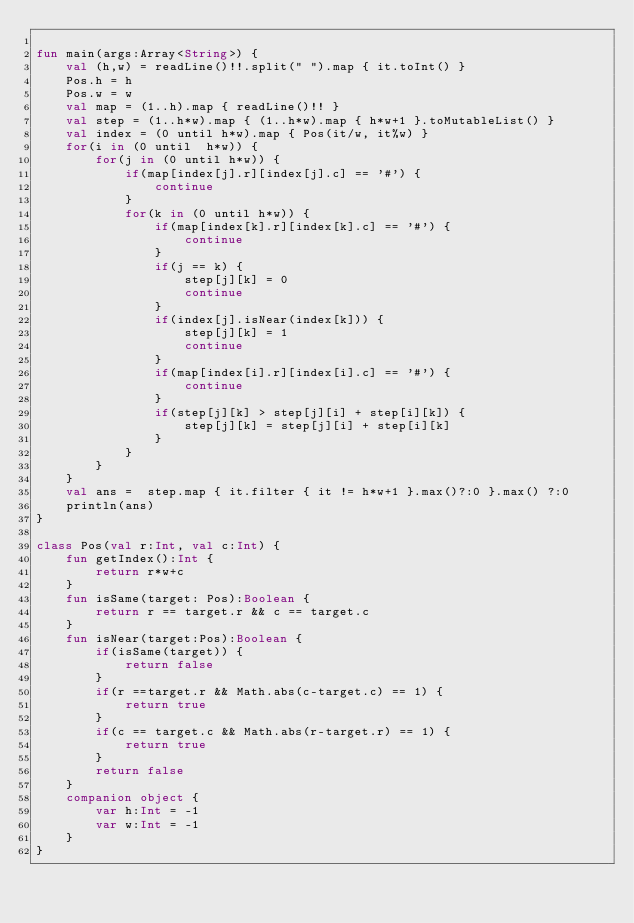Convert code to text. <code><loc_0><loc_0><loc_500><loc_500><_Kotlin_>
fun main(args:Array<String>) {
    val (h,w) = readLine()!!.split(" ").map { it.toInt() }
    Pos.h = h
    Pos.w = w
    val map = (1..h).map { readLine()!! }
    val step = (1..h*w).map { (1..h*w).map { h*w+1 }.toMutableList() }
    val index = (0 until h*w).map { Pos(it/w, it%w) }
    for(i in (0 until  h*w)) {
        for(j in (0 until h*w)) {
            if(map[index[j].r][index[j].c] == '#') {
                continue
            }
            for(k in (0 until h*w)) {
                if(map[index[k].r][index[k].c] == '#') {
                    continue
                }
                if(j == k) {
                    step[j][k] = 0
                    continue
                }
                if(index[j].isNear(index[k])) {
                    step[j][k] = 1
                    continue
                }
                if(map[index[i].r][index[i].c] == '#') {
                    continue
                }
                if(step[j][k] > step[j][i] + step[i][k]) {
                    step[j][k] = step[j][i] + step[i][k]
                }
            }
        }
    }
    val ans =  step.map { it.filter { it != h*w+1 }.max()?:0 }.max() ?:0
    println(ans)
}

class Pos(val r:Int, val c:Int) {
    fun getIndex():Int {
        return r*w+c
    }
    fun isSame(target: Pos):Boolean {
        return r == target.r && c == target.c
    }
    fun isNear(target:Pos):Boolean {
        if(isSame(target)) {
            return false
        }
        if(r ==target.r && Math.abs(c-target.c) == 1) {
            return true
        }
        if(c == target.c && Math.abs(r-target.r) == 1) {
            return true
        }
        return false
    }
    companion object {
        var h:Int = -1
        var w:Int = -1
    }
}</code> 